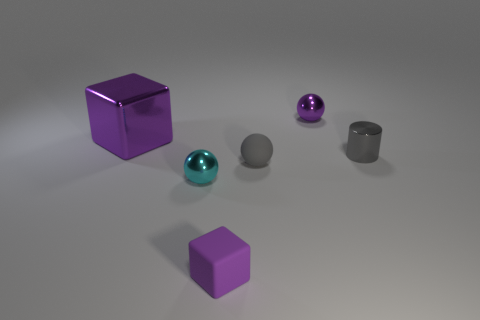Subtract all small purple spheres. How many spheres are left? 2 Subtract all gray spheres. How many spheres are left? 2 Subtract 1 spheres. How many spheres are left? 2 Add 1 tiny gray matte cylinders. How many objects exist? 7 Subtract all blocks. How many objects are left? 4 Subtract all blue spheres. Subtract all green cubes. How many spheres are left? 3 Subtract all purple matte cubes. Subtract all purple cubes. How many objects are left? 3 Add 5 gray spheres. How many gray spheres are left? 6 Add 3 small purple balls. How many small purple balls exist? 4 Subtract 0 green blocks. How many objects are left? 6 